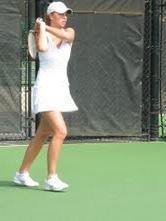How many rackets is the woman holding?
Give a very brief answer. 1. 